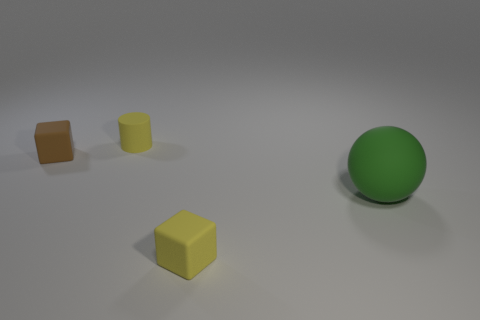How many objects are there in total in the image? There are a total of four objects in the image, consisting of three blocks and one sphere. 
Are there any objects that share the same shape? Yes, two of the blocks share the same cube shape. 